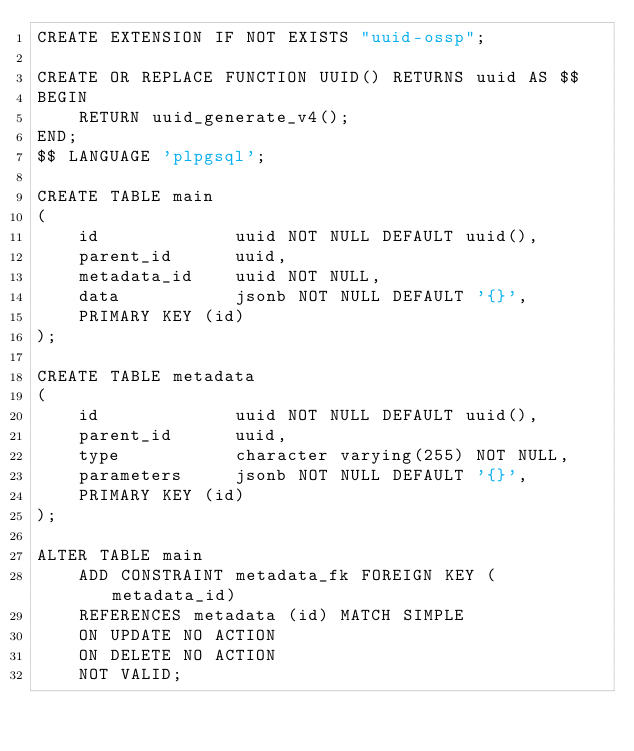Convert code to text. <code><loc_0><loc_0><loc_500><loc_500><_SQL_>CREATE EXTENSION IF NOT EXISTS "uuid-ossp";

CREATE OR REPLACE FUNCTION UUID() RETURNS uuid AS $$
BEGIN
    RETURN uuid_generate_v4();
END;
$$ LANGUAGE 'plpgsql';

CREATE TABLE main
(
    id             uuid NOT NULL DEFAULT uuid(),
    parent_id      uuid,
    metadata_id    uuid NOT NULL,
    data           jsonb NOT NULL DEFAULT '{}',
    PRIMARY KEY (id)
);

CREATE TABLE metadata
(
    id             uuid NOT NULL DEFAULT uuid(),
    parent_id      uuid,
    type           character varying(255) NOT NULL,
    parameters     jsonb NOT NULL DEFAULT '{}',
    PRIMARY KEY (id)
);

ALTER TABLE main
    ADD CONSTRAINT metadata_fk FOREIGN KEY (metadata_id)
    REFERENCES metadata (id) MATCH SIMPLE
    ON UPDATE NO ACTION
    ON DELETE NO ACTION
    NOT VALID;</code> 